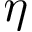Convert formula to latex. <formula><loc_0><loc_0><loc_500><loc_500>\eta</formula> 